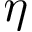Convert formula to latex. <formula><loc_0><loc_0><loc_500><loc_500>\eta</formula> 